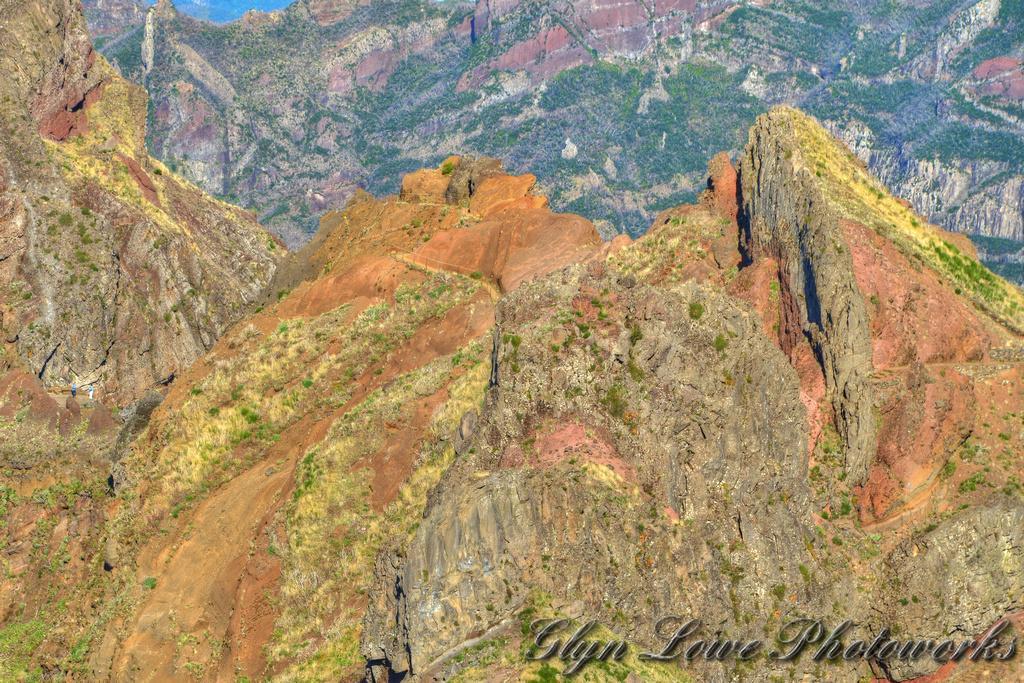How would you summarize this image in a sentence or two? In the picture,there are many mountains of different heights. 